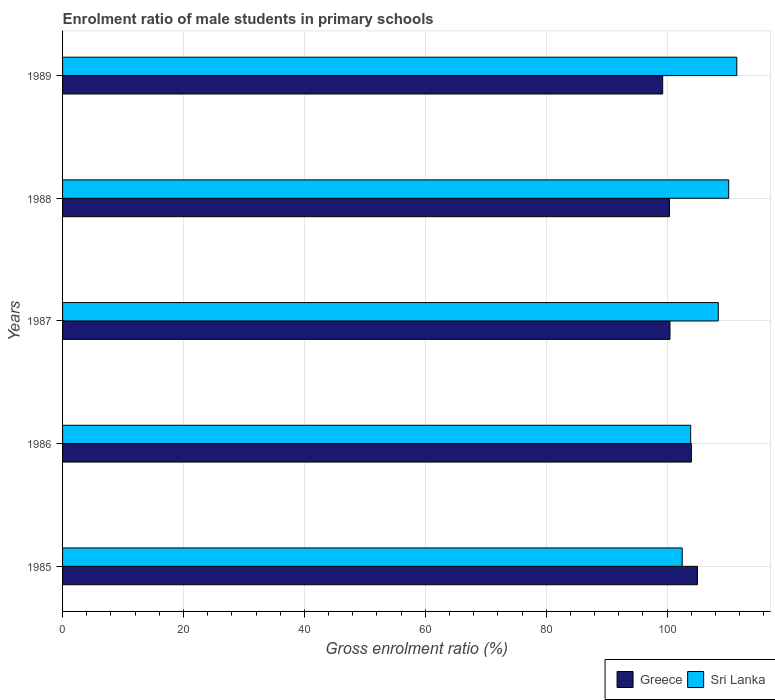How many different coloured bars are there?
Your answer should be very brief. 2. What is the label of the 5th group of bars from the top?
Provide a succinct answer. 1985. What is the enrolment ratio of male students in primary schools in Greece in 1987?
Keep it short and to the point. 100.48. Across all years, what is the maximum enrolment ratio of male students in primary schools in Greece?
Your answer should be very brief. 105.02. Across all years, what is the minimum enrolment ratio of male students in primary schools in Sri Lanka?
Provide a succinct answer. 102.5. In which year was the enrolment ratio of male students in primary schools in Greece minimum?
Make the answer very short. 1989. What is the total enrolment ratio of male students in primary schools in Sri Lanka in the graph?
Give a very brief answer. 536.59. What is the difference between the enrolment ratio of male students in primary schools in Sri Lanka in 1985 and that in 1989?
Your answer should be very brief. -9.03. What is the difference between the enrolment ratio of male students in primary schools in Sri Lanka in 1988 and the enrolment ratio of male students in primary schools in Greece in 1986?
Ensure brevity in your answer.  6.17. What is the average enrolment ratio of male students in primary schools in Sri Lanka per year?
Provide a short and direct response. 107.32. In the year 1989, what is the difference between the enrolment ratio of male students in primary schools in Greece and enrolment ratio of male students in primary schools in Sri Lanka?
Make the answer very short. -12.26. In how many years, is the enrolment ratio of male students in primary schools in Sri Lanka greater than 56 %?
Offer a terse response. 5. What is the ratio of the enrolment ratio of male students in primary schools in Sri Lanka in 1987 to that in 1988?
Ensure brevity in your answer.  0.98. Is the enrolment ratio of male students in primary schools in Greece in 1985 less than that in 1989?
Offer a very short reply. No. Is the difference between the enrolment ratio of male students in primary schools in Greece in 1987 and 1988 greater than the difference between the enrolment ratio of male students in primary schools in Sri Lanka in 1987 and 1988?
Offer a terse response. Yes. What is the difference between the highest and the second highest enrolment ratio of male students in primary schools in Greece?
Provide a short and direct response. 1. What is the difference between the highest and the lowest enrolment ratio of male students in primary schools in Greece?
Keep it short and to the point. 5.75. In how many years, is the enrolment ratio of male students in primary schools in Sri Lanka greater than the average enrolment ratio of male students in primary schools in Sri Lanka taken over all years?
Offer a very short reply. 3. Is the sum of the enrolment ratio of male students in primary schools in Sri Lanka in 1988 and 1989 greater than the maximum enrolment ratio of male students in primary schools in Greece across all years?
Provide a short and direct response. Yes. What does the 2nd bar from the bottom in 1989 represents?
Your answer should be very brief. Sri Lanka. Are the values on the major ticks of X-axis written in scientific E-notation?
Provide a succinct answer. No. How many legend labels are there?
Offer a terse response. 2. How are the legend labels stacked?
Your answer should be very brief. Horizontal. What is the title of the graph?
Provide a short and direct response. Enrolment ratio of male students in primary schools. What is the label or title of the X-axis?
Ensure brevity in your answer.  Gross enrolment ratio (%). What is the Gross enrolment ratio (%) in Greece in 1985?
Give a very brief answer. 105.02. What is the Gross enrolment ratio (%) in Sri Lanka in 1985?
Make the answer very short. 102.5. What is the Gross enrolment ratio (%) in Greece in 1986?
Your response must be concise. 104.02. What is the Gross enrolment ratio (%) in Sri Lanka in 1986?
Give a very brief answer. 103.9. What is the Gross enrolment ratio (%) of Greece in 1987?
Your answer should be very brief. 100.48. What is the Gross enrolment ratio (%) in Sri Lanka in 1987?
Keep it short and to the point. 108.46. What is the Gross enrolment ratio (%) in Greece in 1988?
Make the answer very short. 100.4. What is the Gross enrolment ratio (%) of Sri Lanka in 1988?
Make the answer very short. 110.19. What is the Gross enrolment ratio (%) in Greece in 1989?
Give a very brief answer. 99.27. What is the Gross enrolment ratio (%) in Sri Lanka in 1989?
Your response must be concise. 111.53. Across all years, what is the maximum Gross enrolment ratio (%) of Greece?
Provide a succinct answer. 105.02. Across all years, what is the maximum Gross enrolment ratio (%) of Sri Lanka?
Your answer should be compact. 111.53. Across all years, what is the minimum Gross enrolment ratio (%) of Greece?
Keep it short and to the point. 99.27. Across all years, what is the minimum Gross enrolment ratio (%) of Sri Lanka?
Keep it short and to the point. 102.5. What is the total Gross enrolment ratio (%) in Greece in the graph?
Give a very brief answer. 509.19. What is the total Gross enrolment ratio (%) of Sri Lanka in the graph?
Keep it short and to the point. 536.59. What is the difference between the Gross enrolment ratio (%) of Greece in 1985 and that in 1986?
Provide a succinct answer. 1. What is the difference between the Gross enrolment ratio (%) in Sri Lanka in 1985 and that in 1986?
Your response must be concise. -1.41. What is the difference between the Gross enrolment ratio (%) of Greece in 1985 and that in 1987?
Give a very brief answer. 4.55. What is the difference between the Gross enrolment ratio (%) in Sri Lanka in 1985 and that in 1987?
Your response must be concise. -5.97. What is the difference between the Gross enrolment ratio (%) of Greece in 1985 and that in 1988?
Provide a succinct answer. 4.62. What is the difference between the Gross enrolment ratio (%) of Sri Lanka in 1985 and that in 1988?
Offer a very short reply. -7.69. What is the difference between the Gross enrolment ratio (%) of Greece in 1985 and that in 1989?
Your answer should be very brief. 5.75. What is the difference between the Gross enrolment ratio (%) of Sri Lanka in 1985 and that in 1989?
Give a very brief answer. -9.03. What is the difference between the Gross enrolment ratio (%) in Greece in 1986 and that in 1987?
Ensure brevity in your answer.  3.55. What is the difference between the Gross enrolment ratio (%) of Sri Lanka in 1986 and that in 1987?
Provide a succinct answer. -4.56. What is the difference between the Gross enrolment ratio (%) of Greece in 1986 and that in 1988?
Provide a short and direct response. 3.62. What is the difference between the Gross enrolment ratio (%) in Sri Lanka in 1986 and that in 1988?
Offer a terse response. -6.29. What is the difference between the Gross enrolment ratio (%) of Greece in 1986 and that in 1989?
Make the answer very short. 4.75. What is the difference between the Gross enrolment ratio (%) in Sri Lanka in 1986 and that in 1989?
Provide a short and direct response. -7.62. What is the difference between the Gross enrolment ratio (%) in Greece in 1987 and that in 1988?
Keep it short and to the point. 0.08. What is the difference between the Gross enrolment ratio (%) of Sri Lanka in 1987 and that in 1988?
Make the answer very short. -1.73. What is the difference between the Gross enrolment ratio (%) in Greece in 1987 and that in 1989?
Ensure brevity in your answer.  1.21. What is the difference between the Gross enrolment ratio (%) of Sri Lanka in 1987 and that in 1989?
Ensure brevity in your answer.  -3.06. What is the difference between the Gross enrolment ratio (%) of Greece in 1988 and that in 1989?
Your answer should be compact. 1.13. What is the difference between the Gross enrolment ratio (%) of Sri Lanka in 1988 and that in 1989?
Give a very brief answer. -1.34. What is the difference between the Gross enrolment ratio (%) in Greece in 1985 and the Gross enrolment ratio (%) in Sri Lanka in 1986?
Keep it short and to the point. 1.12. What is the difference between the Gross enrolment ratio (%) in Greece in 1985 and the Gross enrolment ratio (%) in Sri Lanka in 1987?
Your answer should be compact. -3.44. What is the difference between the Gross enrolment ratio (%) of Greece in 1985 and the Gross enrolment ratio (%) of Sri Lanka in 1988?
Ensure brevity in your answer.  -5.17. What is the difference between the Gross enrolment ratio (%) in Greece in 1985 and the Gross enrolment ratio (%) in Sri Lanka in 1989?
Ensure brevity in your answer.  -6.5. What is the difference between the Gross enrolment ratio (%) in Greece in 1986 and the Gross enrolment ratio (%) in Sri Lanka in 1987?
Your response must be concise. -4.44. What is the difference between the Gross enrolment ratio (%) in Greece in 1986 and the Gross enrolment ratio (%) in Sri Lanka in 1988?
Your answer should be compact. -6.17. What is the difference between the Gross enrolment ratio (%) of Greece in 1986 and the Gross enrolment ratio (%) of Sri Lanka in 1989?
Ensure brevity in your answer.  -7.51. What is the difference between the Gross enrolment ratio (%) of Greece in 1987 and the Gross enrolment ratio (%) of Sri Lanka in 1988?
Make the answer very short. -9.72. What is the difference between the Gross enrolment ratio (%) in Greece in 1987 and the Gross enrolment ratio (%) in Sri Lanka in 1989?
Make the answer very short. -11.05. What is the difference between the Gross enrolment ratio (%) of Greece in 1988 and the Gross enrolment ratio (%) of Sri Lanka in 1989?
Your answer should be very brief. -11.13. What is the average Gross enrolment ratio (%) of Greece per year?
Provide a succinct answer. 101.84. What is the average Gross enrolment ratio (%) in Sri Lanka per year?
Ensure brevity in your answer.  107.32. In the year 1985, what is the difference between the Gross enrolment ratio (%) of Greece and Gross enrolment ratio (%) of Sri Lanka?
Make the answer very short. 2.52. In the year 1986, what is the difference between the Gross enrolment ratio (%) in Greece and Gross enrolment ratio (%) in Sri Lanka?
Ensure brevity in your answer.  0.12. In the year 1987, what is the difference between the Gross enrolment ratio (%) of Greece and Gross enrolment ratio (%) of Sri Lanka?
Your response must be concise. -7.99. In the year 1988, what is the difference between the Gross enrolment ratio (%) in Greece and Gross enrolment ratio (%) in Sri Lanka?
Keep it short and to the point. -9.79. In the year 1989, what is the difference between the Gross enrolment ratio (%) of Greece and Gross enrolment ratio (%) of Sri Lanka?
Make the answer very short. -12.26. What is the ratio of the Gross enrolment ratio (%) of Greece in 1985 to that in 1986?
Provide a succinct answer. 1.01. What is the ratio of the Gross enrolment ratio (%) in Sri Lanka in 1985 to that in 1986?
Give a very brief answer. 0.99. What is the ratio of the Gross enrolment ratio (%) in Greece in 1985 to that in 1987?
Give a very brief answer. 1.05. What is the ratio of the Gross enrolment ratio (%) of Sri Lanka in 1985 to that in 1987?
Offer a very short reply. 0.94. What is the ratio of the Gross enrolment ratio (%) in Greece in 1985 to that in 1988?
Offer a terse response. 1.05. What is the ratio of the Gross enrolment ratio (%) of Sri Lanka in 1985 to that in 1988?
Offer a very short reply. 0.93. What is the ratio of the Gross enrolment ratio (%) of Greece in 1985 to that in 1989?
Your response must be concise. 1.06. What is the ratio of the Gross enrolment ratio (%) in Sri Lanka in 1985 to that in 1989?
Your answer should be compact. 0.92. What is the ratio of the Gross enrolment ratio (%) of Greece in 1986 to that in 1987?
Provide a short and direct response. 1.04. What is the ratio of the Gross enrolment ratio (%) in Sri Lanka in 1986 to that in 1987?
Your answer should be compact. 0.96. What is the ratio of the Gross enrolment ratio (%) of Greece in 1986 to that in 1988?
Keep it short and to the point. 1.04. What is the ratio of the Gross enrolment ratio (%) in Sri Lanka in 1986 to that in 1988?
Give a very brief answer. 0.94. What is the ratio of the Gross enrolment ratio (%) in Greece in 1986 to that in 1989?
Make the answer very short. 1.05. What is the ratio of the Gross enrolment ratio (%) of Sri Lanka in 1986 to that in 1989?
Ensure brevity in your answer.  0.93. What is the ratio of the Gross enrolment ratio (%) of Sri Lanka in 1987 to that in 1988?
Give a very brief answer. 0.98. What is the ratio of the Gross enrolment ratio (%) of Greece in 1987 to that in 1989?
Give a very brief answer. 1.01. What is the ratio of the Gross enrolment ratio (%) of Sri Lanka in 1987 to that in 1989?
Your answer should be very brief. 0.97. What is the ratio of the Gross enrolment ratio (%) of Greece in 1988 to that in 1989?
Ensure brevity in your answer.  1.01. What is the ratio of the Gross enrolment ratio (%) in Sri Lanka in 1988 to that in 1989?
Provide a succinct answer. 0.99. What is the difference between the highest and the second highest Gross enrolment ratio (%) in Greece?
Offer a very short reply. 1. What is the difference between the highest and the second highest Gross enrolment ratio (%) of Sri Lanka?
Ensure brevity in your answer.  1.34. What is the difference between the highest and the lowest Gross enrolment ratio (%) of Greece?
Keep it short and to the point. 5.75. What is the difference between the highest and the lowest Gross enrolment ratio (%) of Sri Lanka?
Keep it short and to the point. 9.03. 